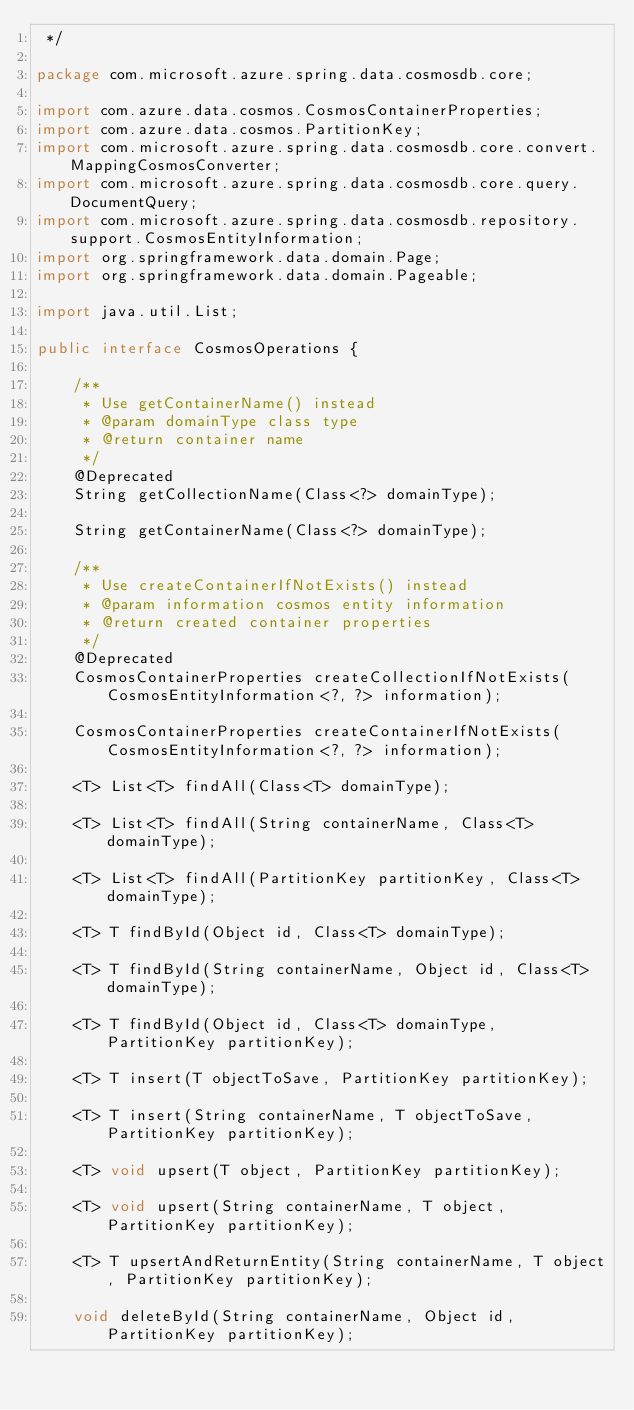Convert code to text. <code><loc_0><loc_0><loc_500><loc_500><_Java_> */

package com.microsoft.azure.spring.data.cosmosdb.core;

import com.azure.data.cosmos.CosmosContainerProperties;
import com.azure.data.cosmos.PartitionKey;
import com.microsoft.azure.spring.data.cosmosdb.core.convert.MappingCosmosConverter;
import com.microsoft.azure.spring.data.cosmosdb.core.query.DocumentQuery;
import com.microsoft.azure.spring.data.cosmosdb.repository.support.CosmosEntityInformation;
import org.springframework.data.domain.Page;
import org.springframework.data.domain.Pageable;

import java.util.List;

public interface CosmosOperations {

    /**
     * Use getContainerName() instead
     * @param domainType class type
     * @return container name
     */
    @Deprecated
    String getCollectionName(Class<?> domainType);

    String getContainerName(Class<?> domainType);

    /**
     * Use createContainerIfNotExists() instead
     * @param information cosmos entity information
     * @return created container properties
     */
    @Deprecated
    CosmosContainerProperties createCollectionIfNotExists(CosmosEntityInformation<?, ?> information);

    CosmosContainerProperties createContainerIfNotExists(CosmosEntityInformation<?, ?> information);

    <T> List<T> findAll(Class<T> domainType);

    <T> List<T> findAll(String containerName, Class<T> domainType);

    <T> List<T> findAll(PartitionKey partitionKey, Class<T> domainType);

    <T> T findById(Object id, Class<T> domainType);

    <T> T findById(String containerName, Object id, Class<T> domainType);

    <T> T findById(Object id, Class<T> domainType, PartitionKey partitionKey);

    <T> T insert(T objectToSave, PartitionKey partitionKey);

    <T> T insert(String containerName, T objectToSave, PartitionKey partitionKey);

    <T> void upsert(T object, PartitionKey partitionKey);

    <T> void upsert(String containerName, T object, PartitionKey partitionKey);

    <T> T upsertAndReturnEntity(String containerName, T object, PartitionKey partitionKey);

    void deleteById(String containerName, Object id, PartitionKey partitionKey);
</code> 